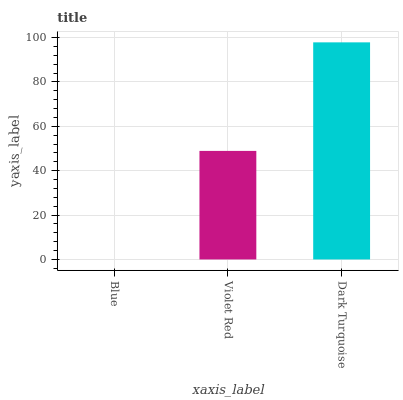Is Blue the minimum?
Answer yes or no. Yes. Is Dark Turquoise the maximum?
Answer yes or no. Yes. Is Violet Red the minimum?
Answer yes or no. No. Is Violet Red the maximum?
Answer yes or no. No. Is Violet Red greater than Blue?
Answer yes or no. Yes. Is Blue less than Violet Red?
Answer yes or no. Yes. Is Blue greater than Violet Red?
Answer yes or no. No. Is Violet Red less than Blue?
Answer yes or no. No. Is Violet Red the high median?
Answer yes or no. Yes. Is Violet Red the low median?
Answer yes or no. Yes. Is Dark Turquoise the high median?
Answer yes or no. No. Is Blue the low median?
Answer yes or no. No. 